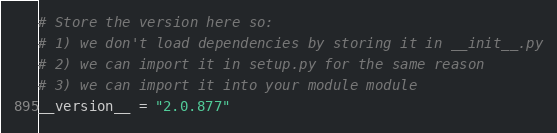Convert code to text. <code><loc_0><loc_0><loc_500><loc_500><_Python_># Store the version here so:
# 1) we don't load dependencies by storing it in __init__.py
# 2) we can import it in setup.py for the same reason
# 3) we can import it into your module module
__version__ = "2.0.877"
</code> 